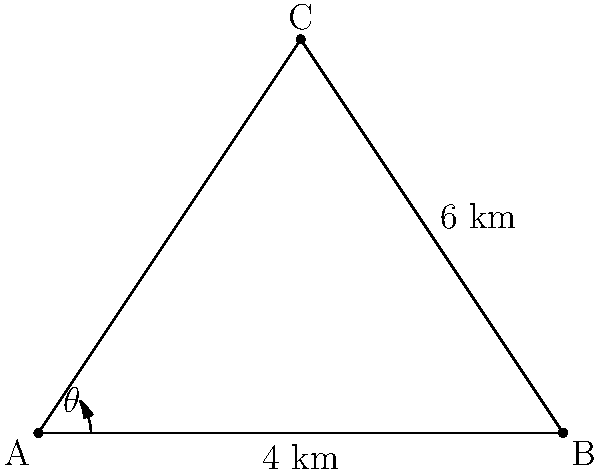On a topographical map, two drilling locations A and B are 4 km apart. A third location C forms a triangle with A and B. The distance from B to C is 6 km, and the angle between AB and AC is $\theta = 36.87°$. Calculate the distance between drilling locations A and C to the nearest 0.1 km. To solve this problem, we'll use the law of cosines:

1) The law of cosines states: $c^2 = a^2 + b^2 - 2ab \cos(C)$

2) In our case:
   - $c$ is the distance AC we're looking for
   - $a = 4$ km (distance AB)
   - $b = 6$ km (distance BC)
   - $C = 180° - 36.87° = 143.13°$ (the angle at B)

3) Substituting these values into the formula:

   $AC^2 = 4^2 + 6^2 - 2(4)(6) \cos(143.13°)$

4) Simplify:
   $AC^2 = 16 + 36 - 48 \cos(143.13°)$

5) Calculate $\cos(143.13°) \approx -0.8$

6) Substitute:
   $AC^2 = 16 + 36 - 48(-0.8) = 16 + 36 + 38.4 = 90.4$

7) Take the square root:
   $AC = \sqrt{90.4} \approx 9.5$ km

8) Rounding to the nearest 0.1 km:
   $AC \approx 9.5$ km
Answer: 9.5 km 